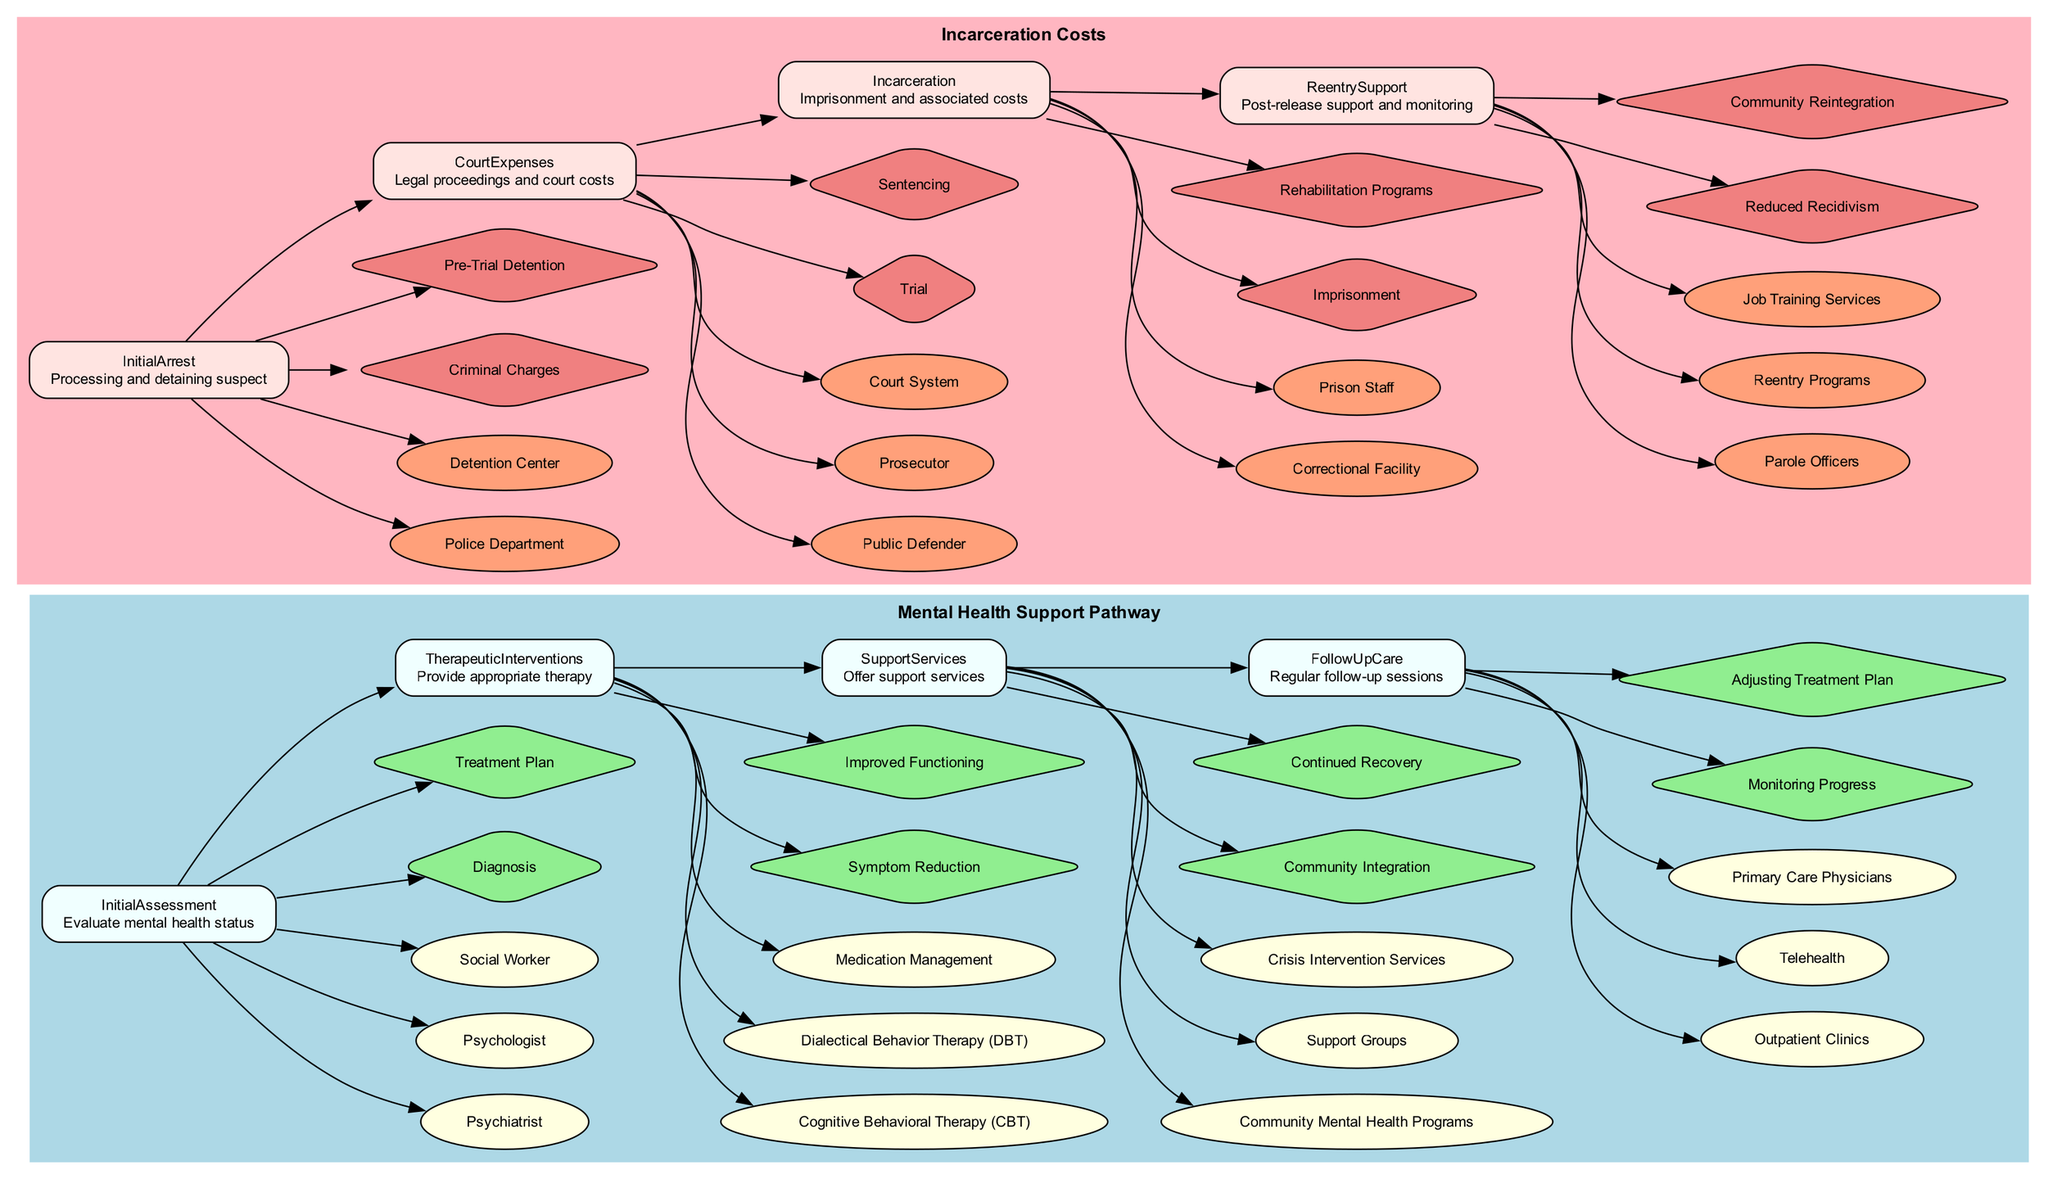What is the first step in the Mental Health Support Pathway? The first step listed in the Mental Health Support Pathway is "Initial Assessment," as presented in the diagram. This node is positioned at the left-most side and is the starting point of the pathway.
Answer: Initial Assessment How many entities are involved in the "Support Services" step? The "Support Services" step includes three entities: "Community Mental Health Programs," "Support Groups," and "Crisis Intervention Services". This can be determined by counting the entities linked to that step in the diagram.
Answer: 3 What is the outcome of the "Court Expenses" node? The "Court Expenses" node has two outcomes: "Trial" and "Sentencing." These outcomes are represented in diamond shapes connected to the node in the diagram.
Answer: Trial, Sentencing Which entity provides the initial assessment in the Mental Health Support Pathway? The entities associated with the "Initial Assessment" include "Psychiatrist," "Psychologist," and "Social Worker." Any of these entities can be considered part of the initial assessment, but the first one in the list is usually the most commonly associated.
Answer: Psychiatrist What is the last step in the Incarceration Costs pathway? The last step in the Incarceration Costs pathway is "Reentry Support," which is the most right node in that section of the diagram. It follows after "Incarceration."
Answer: Reentry Support How many nodes are present in the Mental Health Support Pathway? The Mental Health Support Pathway consists of four main steps (nodes): "Initial Assessment," "Therapeutic Interventions," "Support Services," and "Follow Up Care." Each step is distinctly marked in the diagram.
Answer: 4 What links the "Therapeutic Interventions" to the "Support Services"? The relationship between "Therapeutic Interventions" and "Support Services" is represented by a directed edge (arrow) in the diagram, signifying the flow of processes in the pathway.
Answer: Edge (directed arrow) What are the two outcomes of the "Incarceration" node? The two outcomes for the "Incarceration" node are "Imprisonment" and "Rehabilitation Programs," as identified by the outcomes listed in diamond shapes connected to this node in the diagram.
Answer: Imprisonment, Rehabilitation Programs 